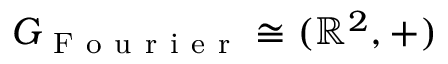<formula> <loc_0><loc_0><loc_500><loc_500>G _ { F o u r i e r } \cong ( \mathbb { R } ^ { 2 } , + )</formula> 